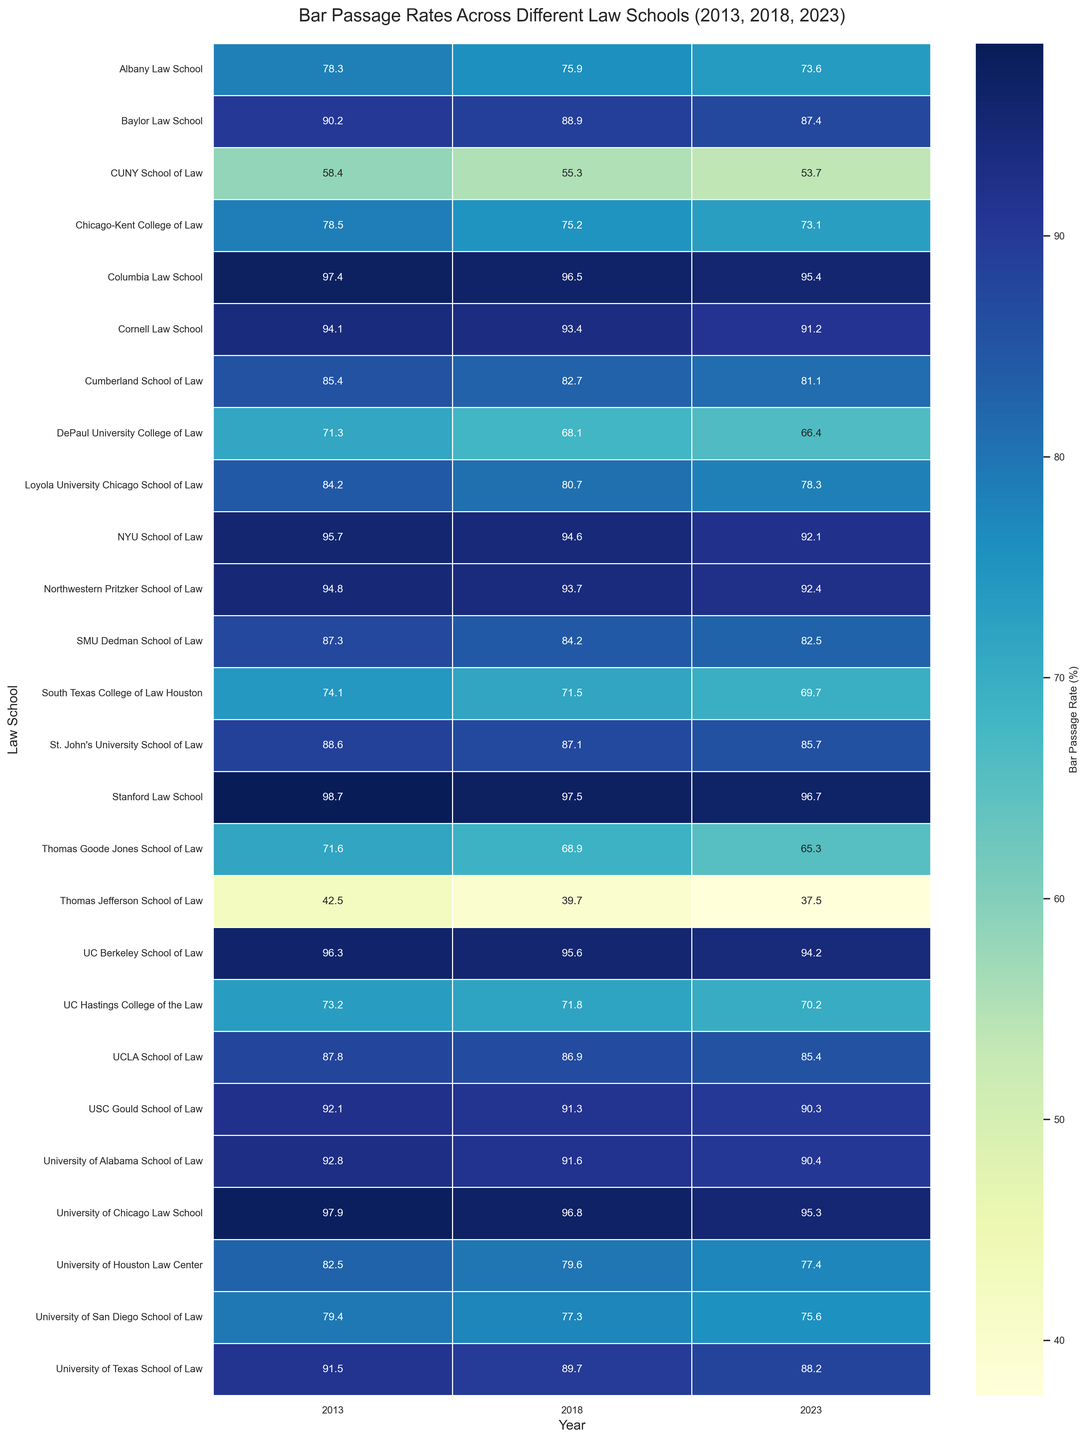What is the bar passage rate of Stanford Law School in 2023? Find Stanford Law School on the y-axis, then trace horizontally to the column labeled 2023 to read the bar passage rate. The bar passage rate for 2023 is 96.7%.
Answer: 96.7% Which law school in California had the lowest bar passage rate in 2018? Focus on the 2018 column and compare the data for all law schools in California. The lowest rate in California for 2018 is Thomas Jefferson School of Law with a rate of 39.7%.
Answer: Thomas Jefferson School of Law What is the average bar passage rate for the University of Alabama School of Law across the years 2013, 2018, and 2023? Locate the bar passage rates for the University of Alabama School of Law for 2013 (92.8%), 2018 (91.6%), and 2023 (90.4%). Calculate the average: (92.8 + 91.6 + 90.4) / 3 ≈ 91.6%.
Answer: 91.6% How did the bar passage rate for CUNY School of Law change from 2013 to 2023? Find the bar passage rates for CUNY School of Law in 2013 (58.4%) and 2023 (53.7%) and compute the difference: 58.4 - 53.7 = 4.7%. This shows a decrease of 4.7% over the period.
Answer: Decreased by 4.7% Compare the bar passage rates of the University of Chicago Law School and Northwestern Pritzker School of Law in 2023. Which one is higher? Locate the bar passage rates for the University of Chicago Law School (95.3%) and Northwestern Pritzker School of Law (92.4%) in 2023. 95.3% is higher than 92.4%.
Answer: University of Chicago Law School What is the median bar passage rate for the law schools in Texas in 2023? First, list the bar passage rates for Texas law schools in 2023: 88.2%, 82.5%, 77.4%, 87.4%, and 69.7%. Arrange them in order: 69.7%, 77.4%, 82.5%, 87.4%, and 88.2%. The median value (middle number) is 82.5%.
Answer: 82.5% Which law school showed the largest decrease in bar passage rate from 2013 to 2023? Calculate the difference in bar passage rates from 2013 to 2023 for all law schools and identify the largest decrease. For example, Thomas Jefferson School of Law decreased from 42.5% (2013) to 37.5% (2023), which is a decrease of 5%. Calculate for all law schools and find the largest.
Answer: Thomas Goode Jones School of Law What is the bar passage rate trend for the University of Houston Law Center over the years? Trace the bar passage rates of the University of Houston Law Center for 2013 (82.5%), 2018 (79.6%), and 2023 (77.4%). The rate is decreasing over the years.
Answer: Decreasing trend Which New York law school had the closest bar passage rates in 2013 and 2023? Compare the 2013 and 2023 bar passage rates of all New York law schools. Columbia Law School has rates of 97.4% (2013) and 95.4% (2023), which are very close compared to other schools.
Answer: Columbia Law School What is the overall trend in bar passage rates for the University of San Diego School of Law from 2013 to 2023? Locate the bar passage rates for the University of San Diego School of Law for 2013 (79.4%), 2018 (77.3%), and 2023 (75.6%). The trend shows a consistent decrease.
Answer: Decreasing trend 